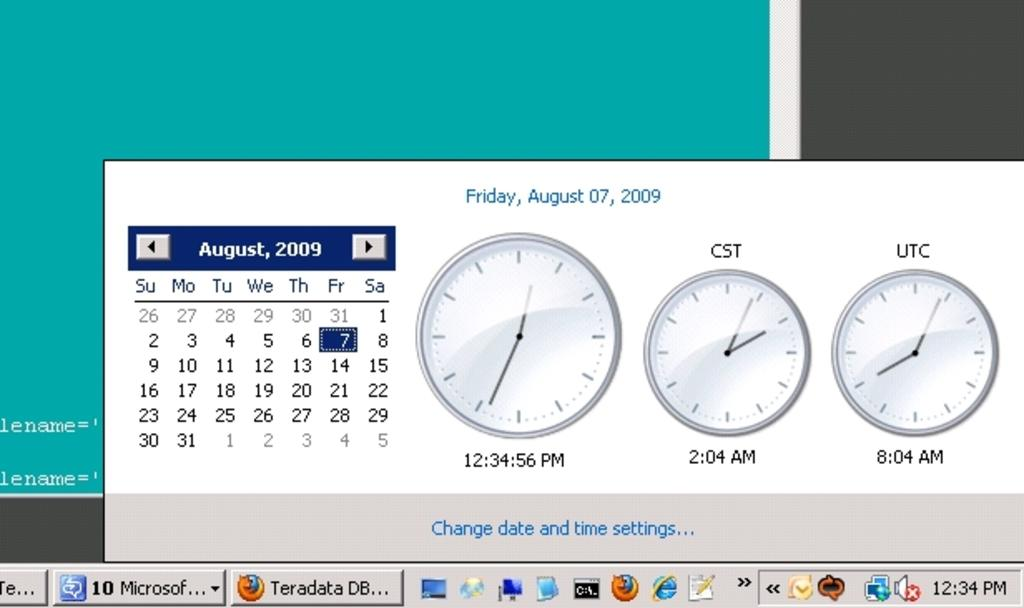<image>
Render a clear and concise summary of the photo. A computer screen showing the date August 7, 2009. 